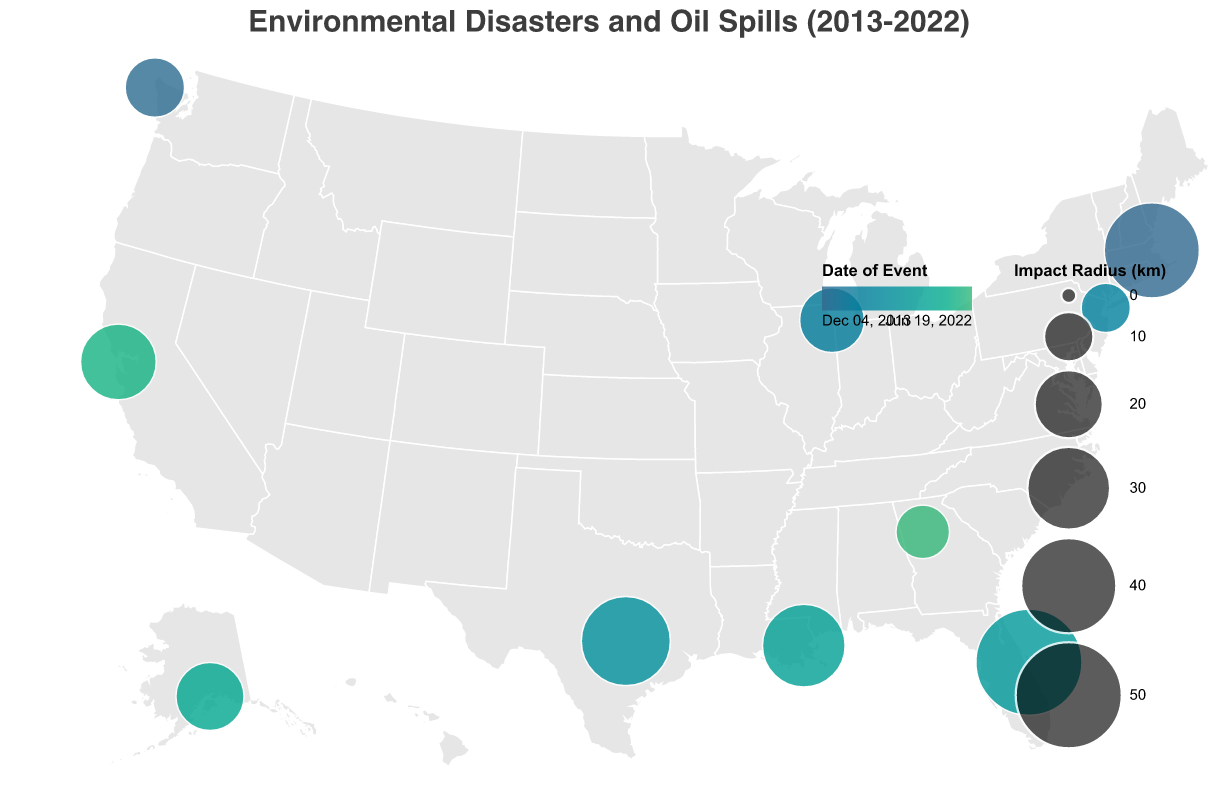What's the title of the figure? The title of the figure is always displayed at the top, usually in a larger font size. Look at the text at the very top of the figure.
Answer: Environmental Disasters and Oil Spills (2013-2022) How many environmental disasters are plotted on the map? Count the number of distinct circles representing different environmental disasters on the map.
Answer: 10 Which city experienced the environmental disaster with the largest impact radius? Look for the largest circle on the geographic plot and check the tooltip or the legend for the corresponding location.
Answer: Cape Canaveral What is the range of impact radii shown in the figure? Identify the smallest and largest circles. Check their tooltips to find the smallest and largest values of Impact Radius (km).
Answer: 10 km to 50 km Which year had the most environmental disasters occurring according to the plot? Examine the color gradient or use the tooltips to count the number of events occurring in each year.
Answer: 2019 How does the event in Austin compare in terms of impact radius with the event in Chicago? Check both locations on the map, read their tooltips for the radius values, and compare them.
Answer: Austin has a larger impact radius (35 km) compared to Chicago (18 km) Between Boston and Anchorage, which city had an event earlier? Look at both locations, find their dates in the tooltip, and compare the dates.
Answer: Boston (2013-12-05) What is the median impact radius of all plotted environmental disasters? List all the impact radii (15, 30, 10, 25, 50, 20, 35, 18, 12, 40), sort them (10, 12, 15, 18, 20, 25, 30, 35, 40, 50), and find the middle value.
Answer: 22.5 km Are there more events in coastal areas or inland areas? Identify the locations of the events on the map. Count how many are along the coast versus inland.
Answer: More events in coastal areas Do newer or older events tend to have a larger impact radius? Check the color-coded dates and associated radii. Compare them to see if there's a trend related to the event date and impact radius.
Answer: Newer events tend to have a larger impact radius 